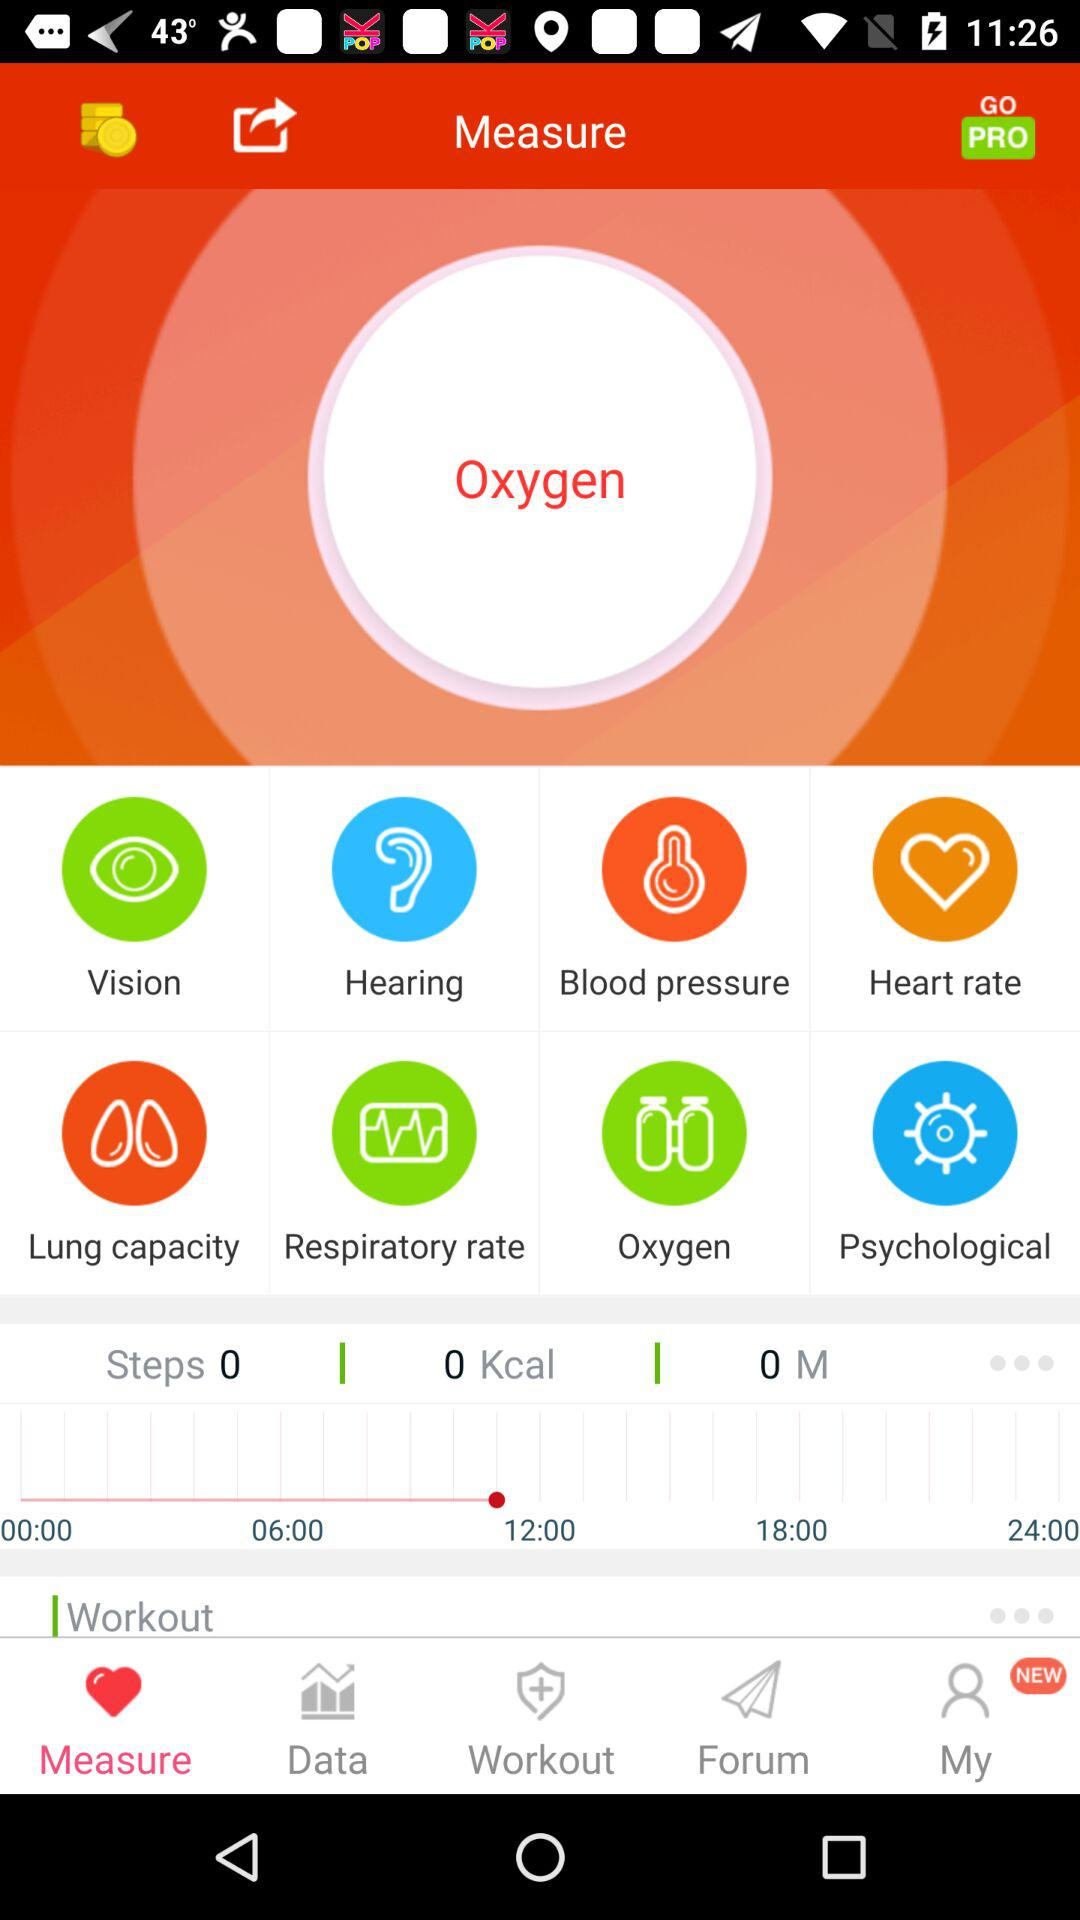What are all the parameters? The parameters are "Vision", "Hearing", "Blood pressure", "Heart rate", "Lung capacity", "Respiratory rate", "Oxygen" and "Psychological". 